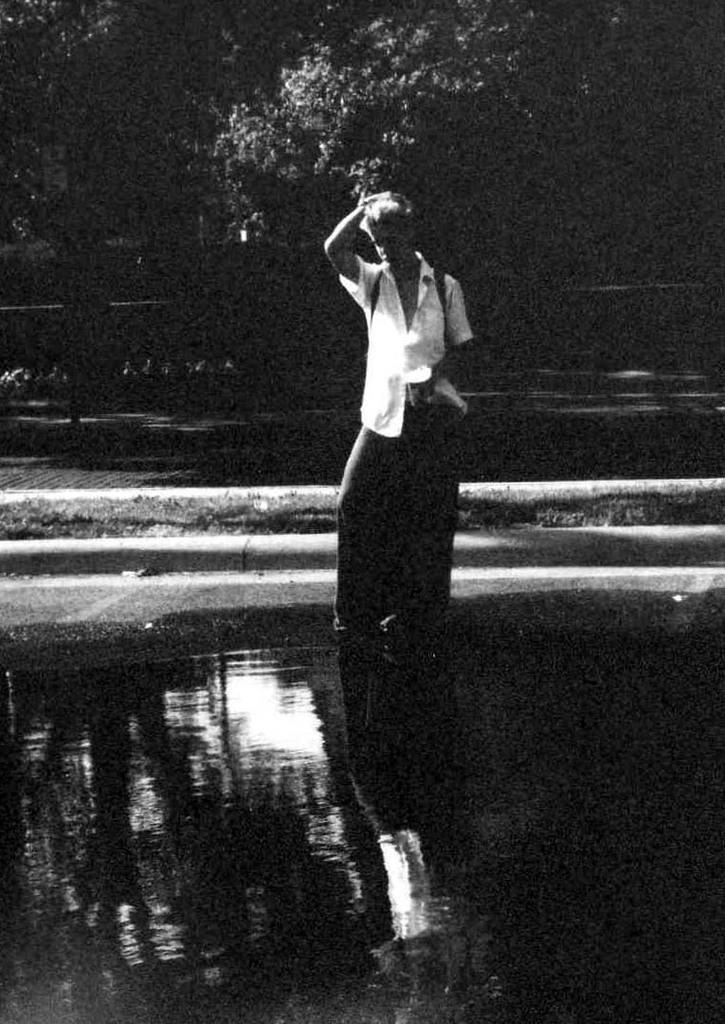Can you describe this image briefly? This is a black and white picture, in this image we can see a person wearing a bag and standing in the water, in the background, we can see the trees. 